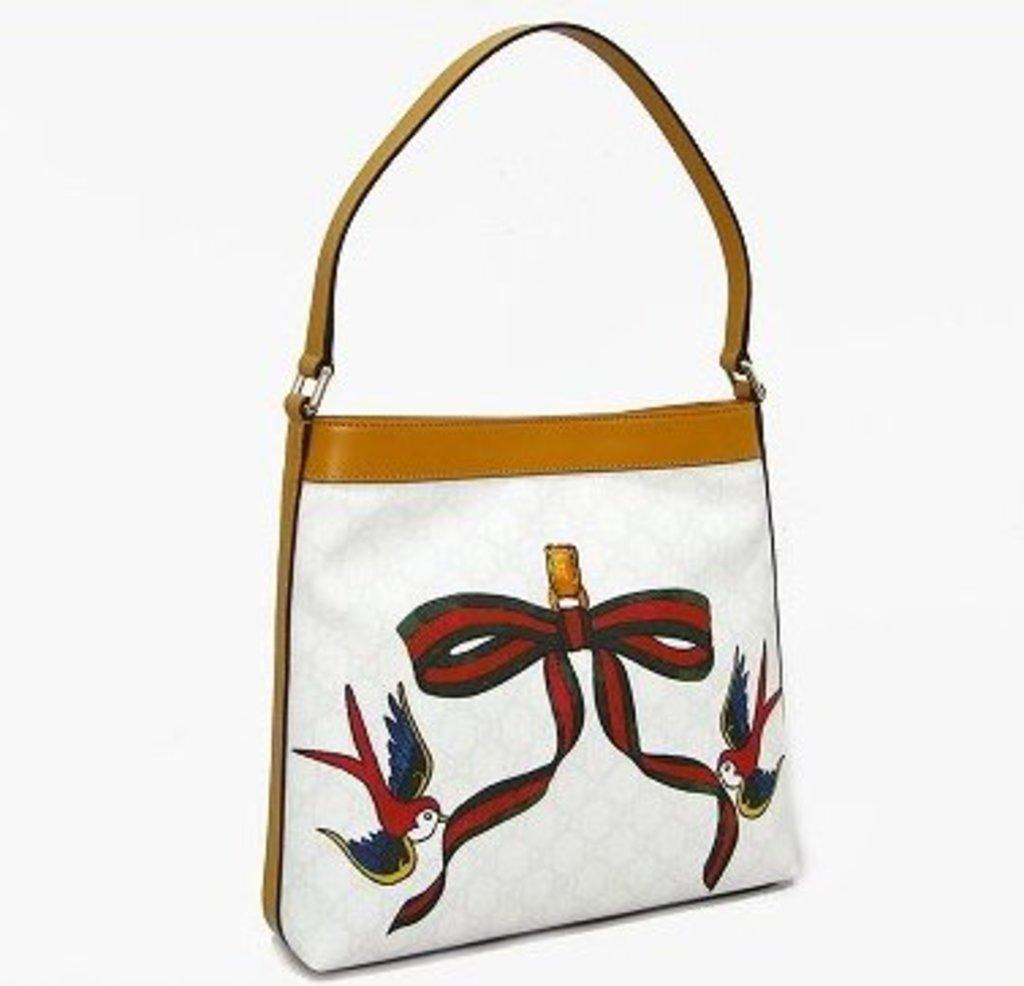What object is featured in the image? There is a handbag in the image. What is depicted on the handbag? There is a painting on the handbag. What type of statement can be seen on the handbag in the image? There is no statement visible on the handbag in the image; it only features a painting. How does the rain affect the appearance of the handbag in the image? There is no rain present in the image, so its effect on the handbag cannot be determined. 